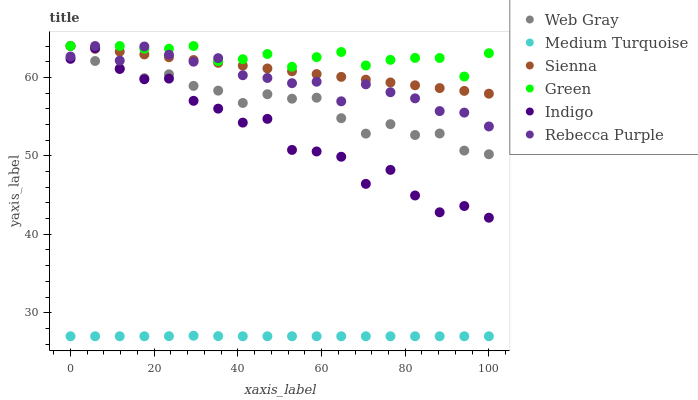Does Medium Turquoise have the minimum area under the curve?
Answer yes or no. Yes. Does Green have the maximum area under the curve?
Answer yes or no. Yes. Does Indigo have the minimum area under the curve?
Answer yes or no. No. Does Indigo have the maximum area under the curve?
Answer yes or no. No. Is Sienna the smoothest?
Answer yes or no. Yes. Is Indigo the roughest?
Answer yes or no. Yes. Is Indigo the smoothest?
Answer yes or no. No. Is Sienna the roughest?
Answer yes or no. No. Does Medium Turquoise have the lowest value?
Answer yes or no. Yes. Does Indigo have the lowest value?
Answer yes or no. No. Does Rebecca Purple have the highest value?
Answer yes or no. Yes. Does Indigo have the highest value?
Answer yes or no. No. Is Medium Turquoise less than Indigo?
Answer yes or no. Yes. Is Sienna greater than Medium Turquoise?
Answer yes or no. Yes. Does Rebecca Purple intersect Green?
Answer yes or no. Yes. Is Rebecca Purple less than Green?
Answer yes or no. No. Is Rebecca Purple greater than Green?
Answer yes or no. No. Does Medium Turquoise intersect Indigo?
Answer yes or no. No. 